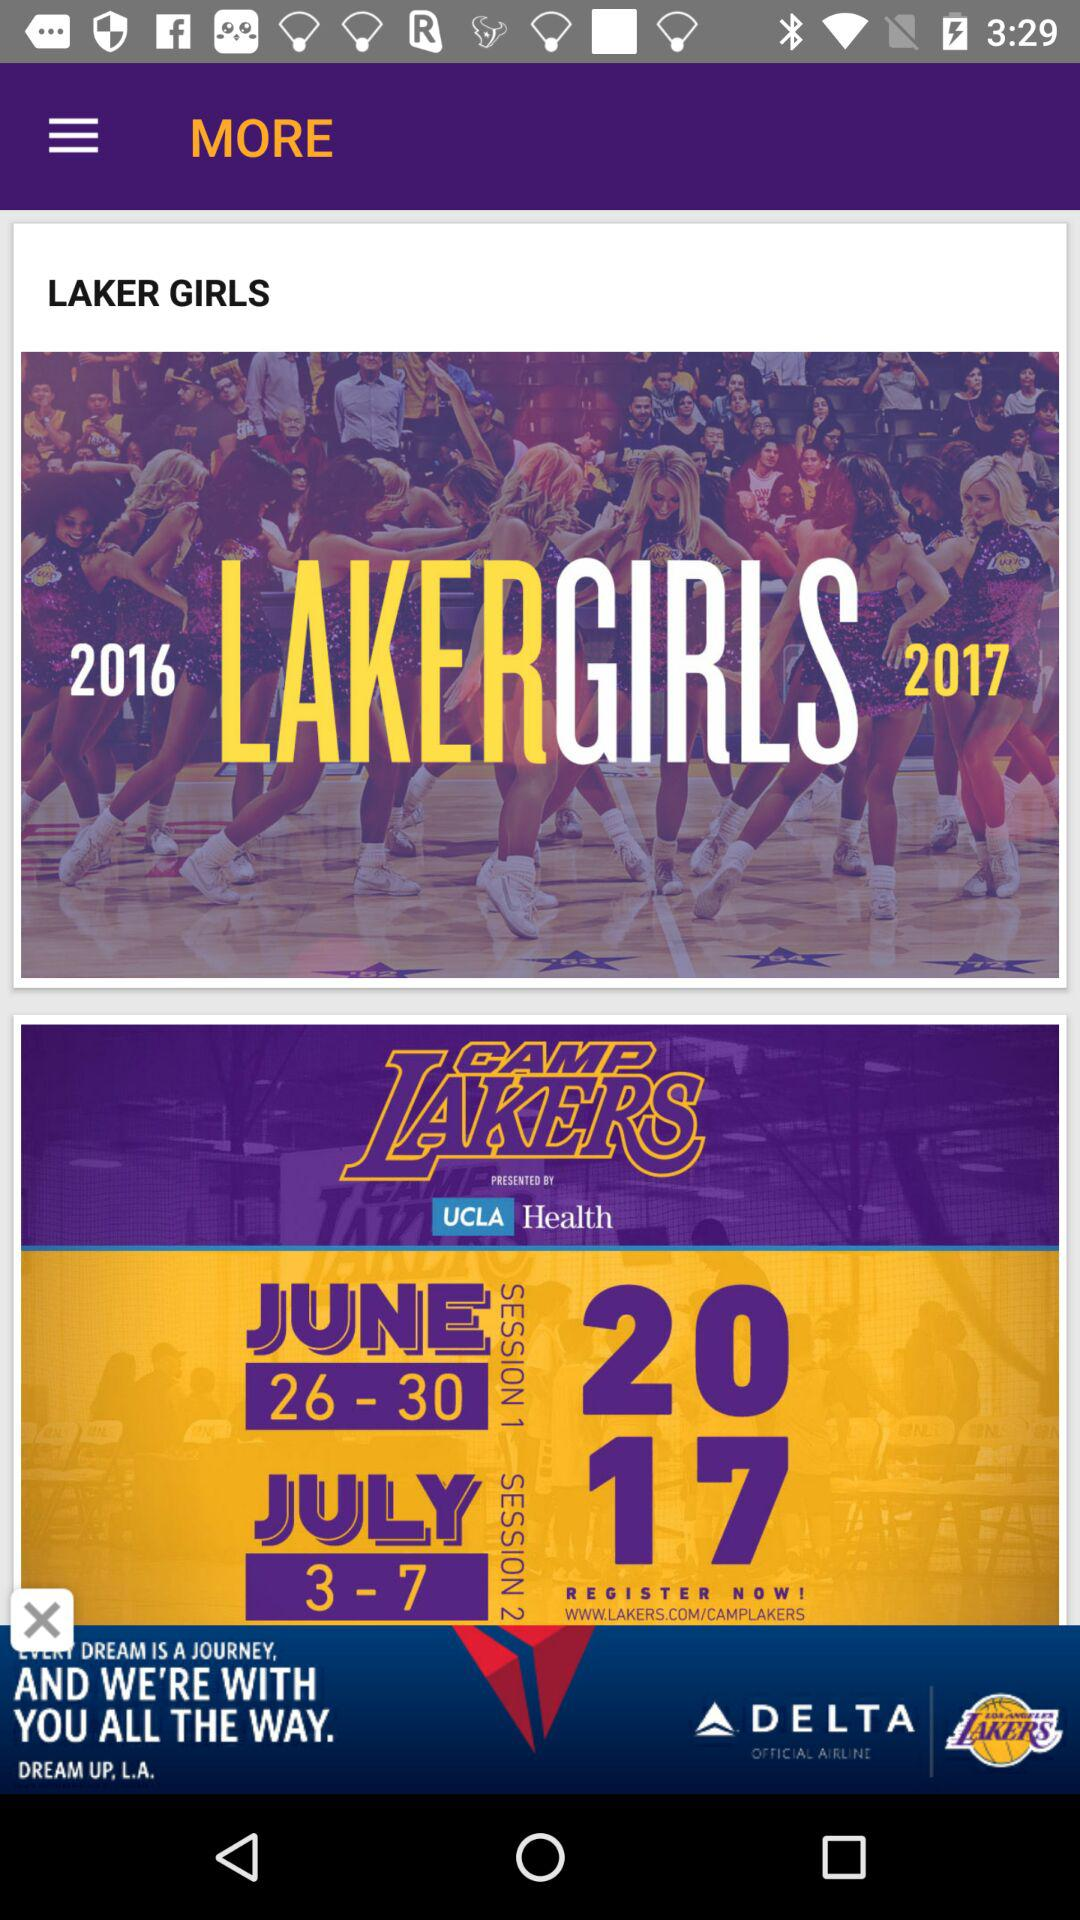How many years are represented in the Lakers Girls section?
Answer the question using a single word or phrase. 2 